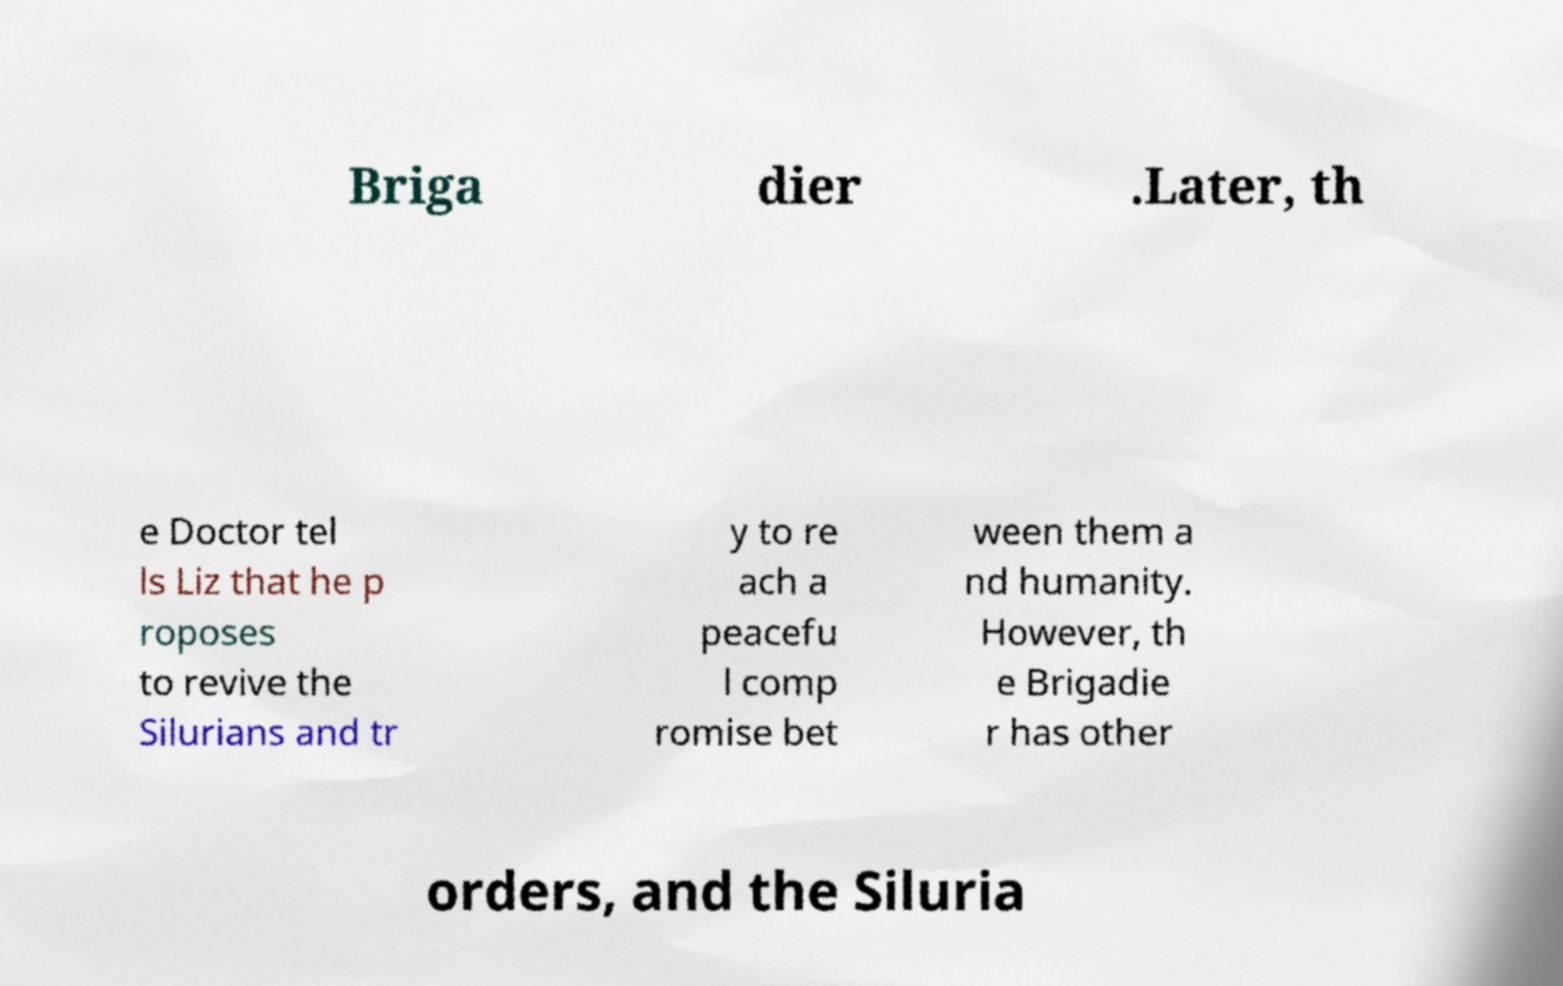Can you read and provide the text displayed in the image?This photo seems to have some interesting text. Can you extract and type it out for me? Briga dier .Later, th e Doctor tel ls Liz that he p roposes to revive the Silurians and tr y to re ach a peacefu l comp romise bet ween them a nd humanity. However, th e Brigadie r has other orders, and the Siluria 